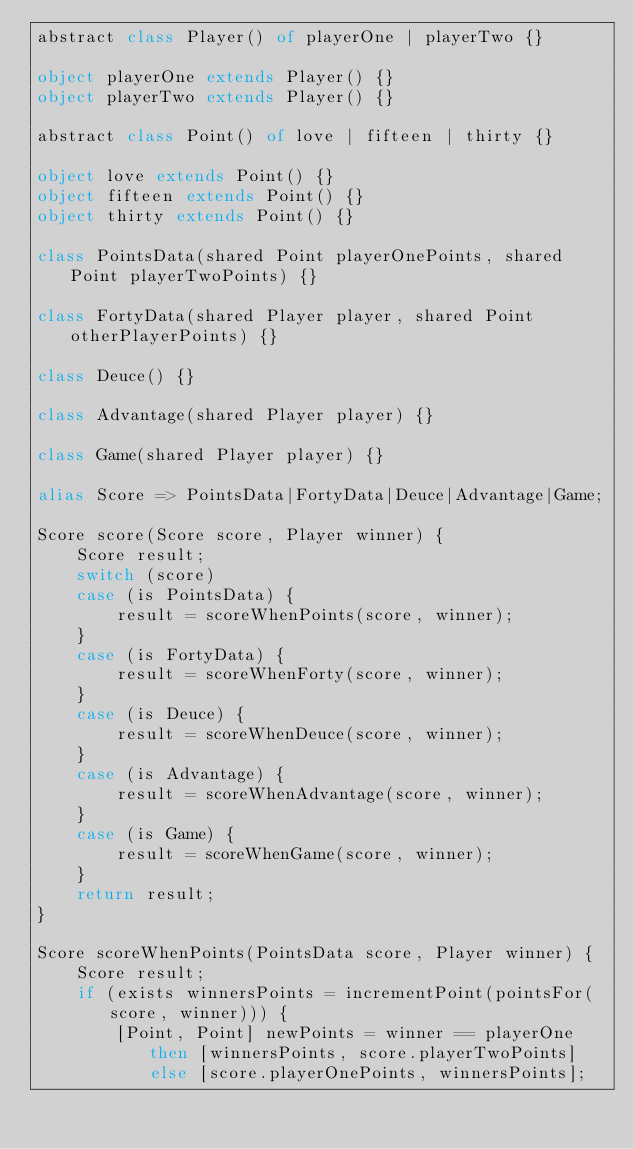<code> <loc_0><loc_0><loc_500><loc_500><_Ceylon_>abstract class Player() of playerOne | playerTwo {}

object playerOne extends Player() {}
object playerTwo extends Player() {}

abstract class Point() of love | fifteen | thirty {}

object love extends Point() {}
object fifteen extends Point() {}
object thirty extends Point() {}

class PointsData(shared Point playerOnePoints, shared Point playerTwoPoints) {}

class FortyData(shared Player player, shared Point otherPlayerPoints) {}

class Deuce() {}

class Advantage(shared Player player) {}

class Game(shared Player player) {}

alias Score => PointsData|FortyData|Deuce|Advantage|Game;

Score score(Score score, Player winner) {
    Score result;
    switch (score)
    case (is PointsData) {
        result = scoreWhenPoints(score, winner);
    }
    case (is FortyData) {
        result = scoreWhenForty(score, winner);
    }
    case (is Deuce) {
        result = scoreWhenDeuce(score, winner);
    }
    case (is Advantage) {
        result = scoreWhenAdvantage(score, winner);
    }
    case (is Game) {
        result = scoreWhenGame(score, winner);
    }
    return result;
}

Score scoreWhenPoints(PointsData score, Player winner) {
    Score result;
    if (exists winnersPoints = incrementPoint(pointsFor(score, winner))) {
        [Point, Point] newPoints = winner == playerOne then [winnersPoints, score.playerTwoPoints] else [score.playerOnePoints, winnersPoints];</code> 